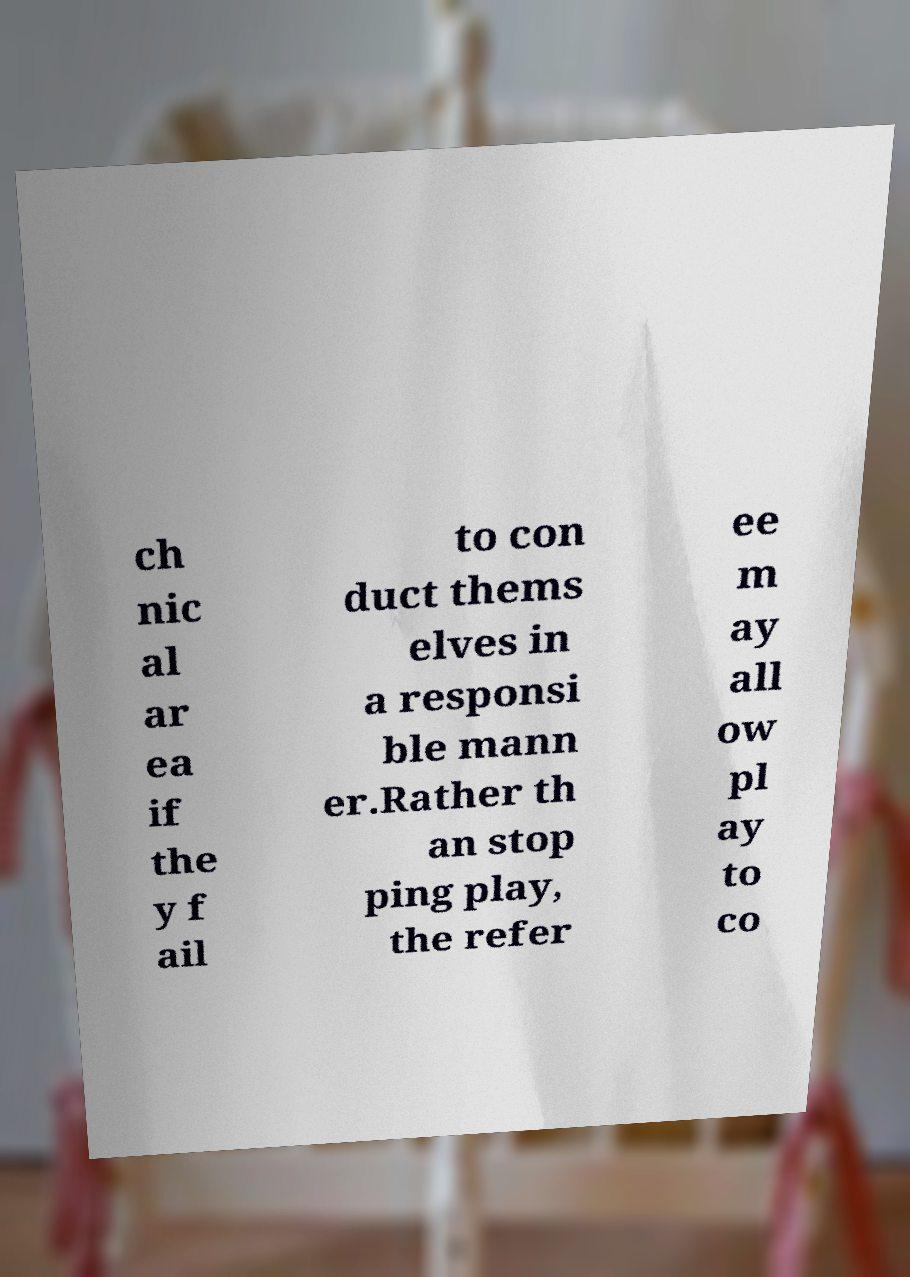Please identify and transcribe the text found in this image. ch nic al ar ea if the y f ail to con duct thems elves in a responsi ble mann er.Rather th an stop ping play, the refer ee m ay all ow pl ay to co 